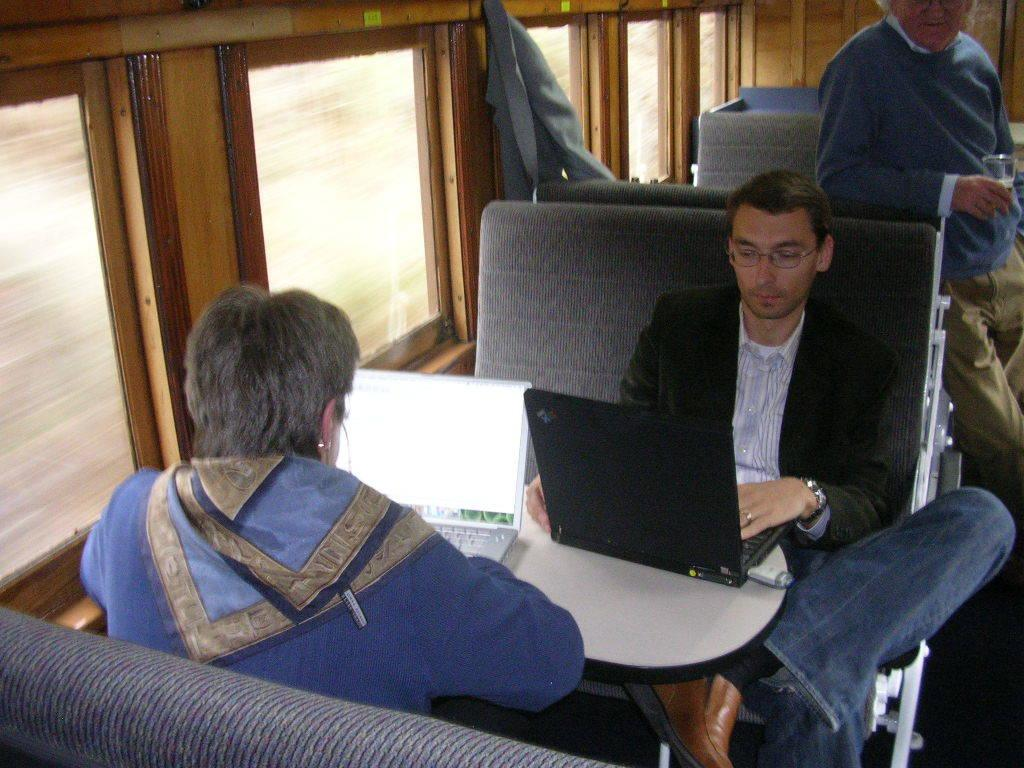How many people are in the image? There are three people in the image. What are two of the people doing in the image? Two of the people are sitting and operating laptops. What can be seen through the windows in the image? The presence of windows suggests that there is a view of the outside, but the specifics are not mentioned in the facts. What other objects can be seen in the image? There are other objects in the image, but the specifics are not mentioned in the facts}. What type of nerve can be seen connecting the two sitting people in the image? There is no nerve connecting the two sitting people in the image; they are operating laptops independently. 